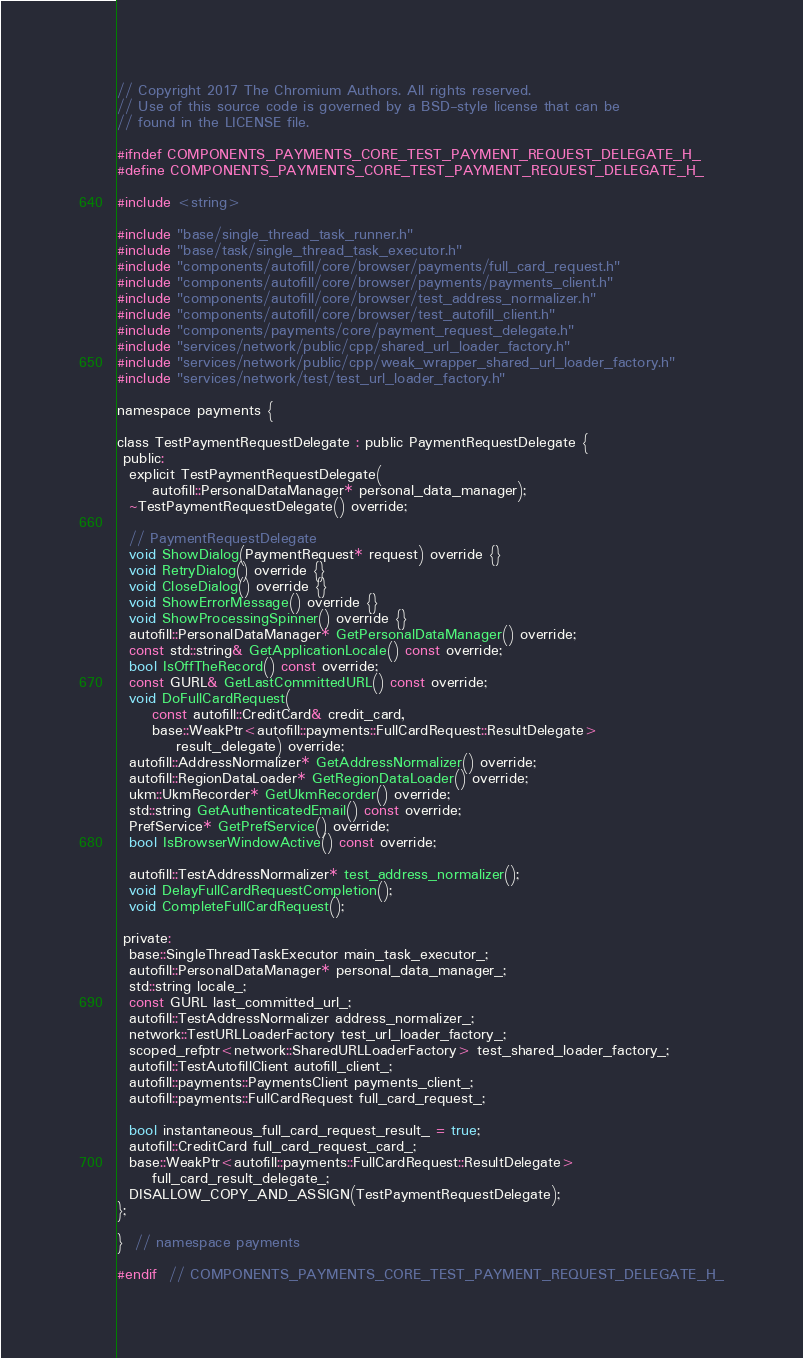<code> <loc_0><loc_0><loc_500><loc_500><_C_>// Copyright 2017 The Chromium Authors. All rights reserved.
// Use of this source code is governed by a BSD-style license that can be
// found in the LICENSE file.

#ifndef COMPONENTS_PAYMENTS_CORE_TEST_PAYMENT_REQUEST_DELEGATE_H_
#define COMPONENTS_PAYMENTS_CORE_TEST_PAYMENT_REQUEST_DELEGATE_H_

#include <string>

#include "base/single_thread_task_runner.h"
#include "base/task/single_thread_task_executor.h"
#include "components/autofill/core/browser/payments/full_card_request.h"
#include "components/autofill/core/browser/payments/payments_client.h"
#include "components/autofill/core/browser/test_address_normalizer.h"
#include "components/autofill/core/browser/test_autofill_client.h"
#include "components/payments/core/payment_request_delegate.h"
#include "services/network/public/cpp/shared_url_loader_factory.h"
#include "services/network/public/cpp/weak_wrapper_shared_url_loader_factory.h"
#include "services/network/test/test_url_loader_factory.h"

namespace payments {

class TestPaymentRequestDelegate : public PaymentRequestDelegate {
 public:
  explicit TestPaymentRequestDelegate(
      autofill::PersonalDataManager* personal_data_manager);
  ~TestPaymentRequestDelegate() override;

  // PaymentRequestDelegate
  void ShowDialog(PaymentRequest* request) override {}
  void RetryDialog() override {}
  void CloseDialog() override {}
  void ShowErrorMessage() override {}
  void ShowProcessingSpinner() override {}
  autofill::PersonalDataManager* GetPersonalDataManager() override;
  const std::string& GetApplicationLocale() const override;
  bool IsOffTheRecord() const override;
  const GURL& GetLastCommittedURL() const override;
  void DoFullCardRequest(
      const autofill::CreditCard& credit_card,
      base::WeakPtr<autofill::payments::FullCardRequest::ResultDelegate>
          result_delegate) override;
  autofill::AddressNormalizer* GetAddressNormalizer() override;
  autofill::RegionDataLoader* GetRegionDataLoader() override;
  ukm::UkmRecorder* GetUkmRecorder() override;
  std::string GetAuthenticatedEmail() const override;
  PrefService* GetPrefService() override;
  bool IsBrowserWindowActive() const override;

  autofill::TestAddressNormalizer* test_address_normalizer();
  void DelayFullCardRequestCompletion();
  void CompleteFullCardRequest();

 private:
  base::SingleThreadTaskExecutor main_task_executor_;
  autofill::PersonalDataManager* personal_data_manager_;
  std::string locale_;
  const GURL last_committed_url_;
  autofill::TestAddressNormalizer address_normalizer_;
  network::TestURLLoaderFactory test_url_loader_factory_;
  scoped_refptr<network::SharedURLLoaderFactory> test_shared_loader_factory_;
  autofill::TestAutofillClient autofill_client_;
  autofill::payments::PaymentsClient payments_client_;
  autofill::payments::FullCardRequest full_card_request_;

  bool instantaneous_full_card_request_result_ = true;
  autofill::CreditCard full_card_request_card_;
  base::WeakPtr<autofill::payments::FullCardRequest::ResultDelegate>
      full_card_result_delegate_;
  DISALLOW_COPY_AND_ASSIGN(TestPaymentRequestDelegate);
};

}  // namespace payments

#endif  // COMPONENTS_PAYMENTS_CORE_TEST_PAYMENT_REQUEST_DELEGATE_H_
</code> 